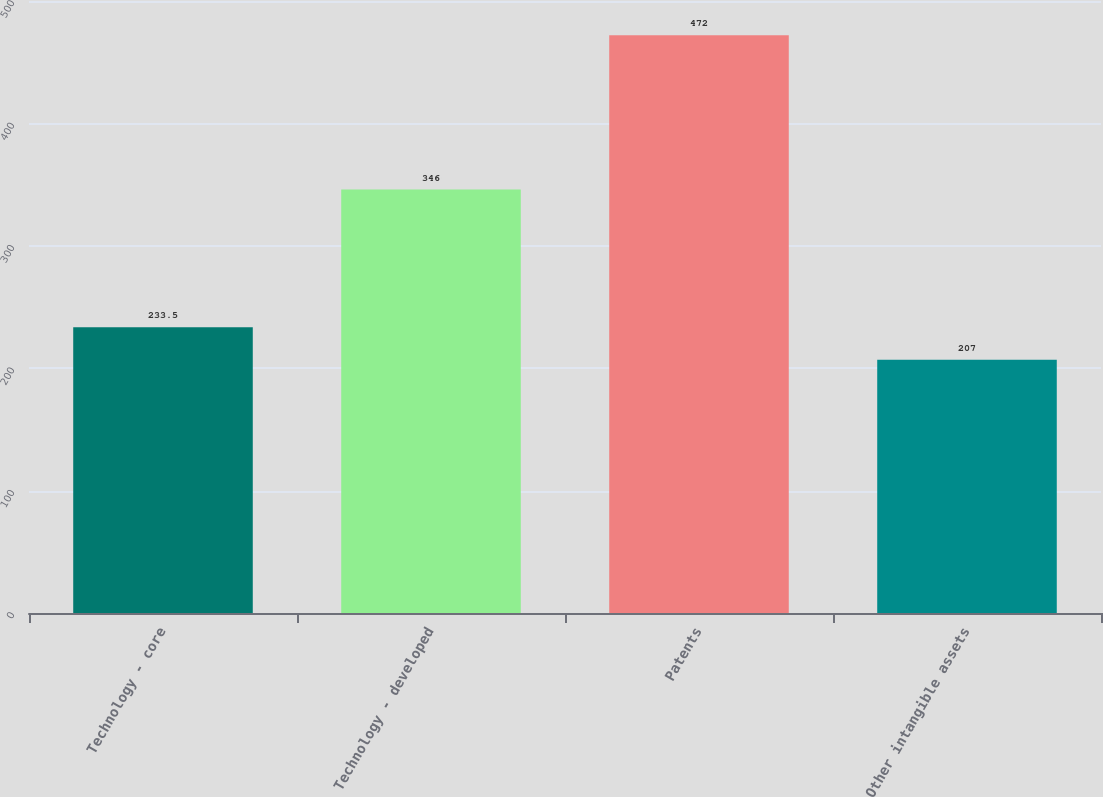<chart> <loc_0><loc_0><loc_500><loc_500><bar_chart><fcel>Technology - core<fcel>Technology - developed<fcel>Patents<fcel>Other intangible assets<nl><fcel>233.5<fcel>346<fcel>472<fcel>207<nl></chart> 